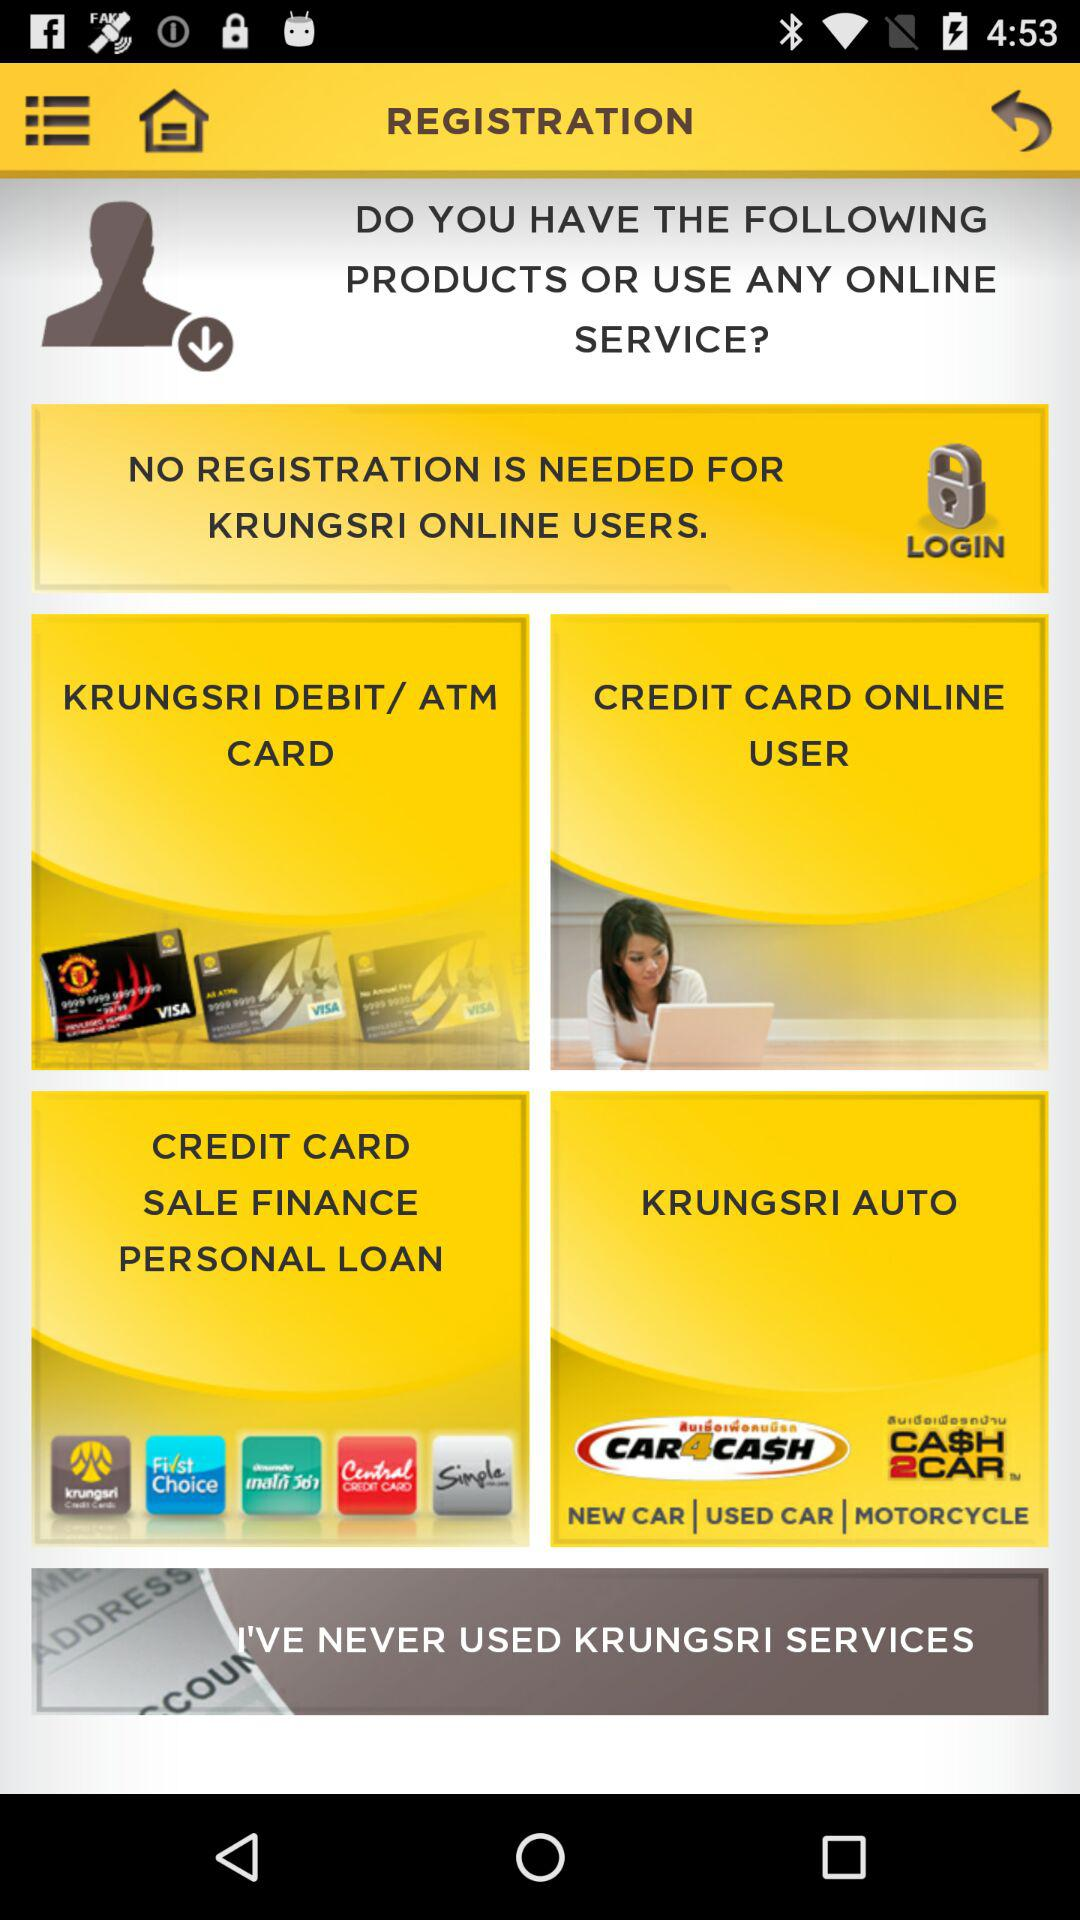For which users is registration not needed? No registration is needed for "KRUNGSRI" online users. 